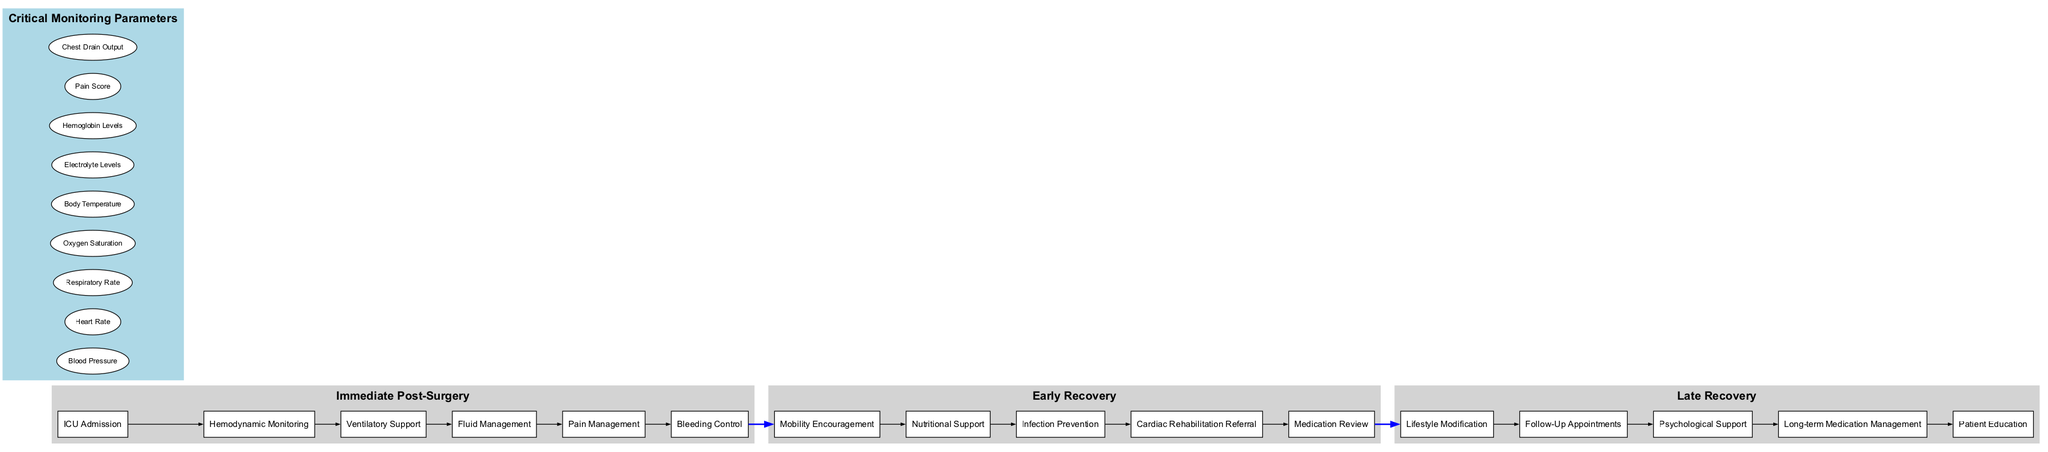What is the first stage in the Clinical Pathway? The first stage listed in the diagram is "Immediate Post-Surgery." It is the initial step outlined in the Clinical Pathway for cardiac patients.
Answer: Immediate Post-Surgery How many key elements are there in the Early Recovery stage? The Early Recovery stage has five key elements, as indicated by the number of boxes within that section of the diagram.
Answer: 5 Which element is related to oxygenation in the Immediate Post-Surgery stage? The element related to oxygenation in the Immediate Post-Surgery stage is "Ventilatory Support," as it specifically addresses mechanical ventilation and ensuring adequate oxygenation.
Answer: Ventilatory Support What is the last key element in the Late Recovery stage? The last key element indicated in the Late Recovery stage is "Patient Education," which is positioned at the end of that section, as seen in the diagram layout.
Answer: Patient Education How do the Early Recovery and Late Recovery stages connect? The "Medication Review" element in the Early Recovery stage connects to the "Lifestyle Modification" element in the Late Recovery stage, which is clearly shown by the directed edge between them in the diagram.
Answer: Medication Review to Lifestyle Modification What critical monitoring parameter is related to fluid levels? The "Electrolyte Levels" parameter is related to fluid levels and is one of the critical monitoring parameters mentioned in the diagram.
Answer: Electrolyte Levels How many critical monitoring parameters are displayed in the diagram? There are eight critical monitoring parameters listed, which can be counted directly from the illustrated section of the diagram.
Answer: 8 Which stage includes "Psychological Support"? The "Psychological Support" element is found in the Late Recovery stage, as indicated by its placement within that specific section of the diagram.
Answer: Late Recovery What is the purpose of the "Infection Prevention" element in the Early Recovery stage? The "Infection Prevention" element aims to administer prophylactic antibiotics and monitor for signs of infection, which is clearly described in the diagram.
Answer: Administer prophylactic antibiotics and monitor for signs of infection 